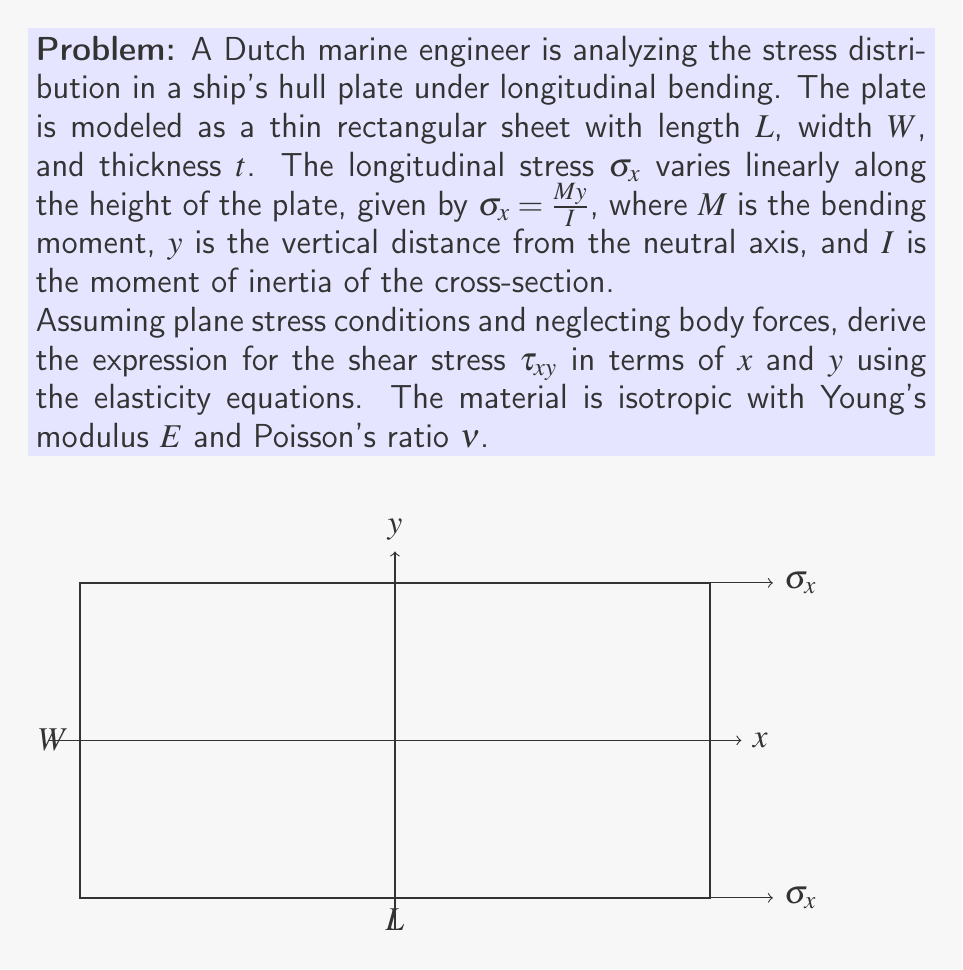Solve this math problem. To solve this problem, we'll use the elasticity equations and follow these steps:

1) First, recall the equilibrium equation for plane stress in the x-direction:

   $$\frac{\partial \sigma_x}{\partial x} + \frac{\partial \tau_{xy}}{\partial y} = 0$$

2) We're given that $\sigma_x = \frac{My}{I}$. Note that this is independent of $x$, so $\frac{\partial \sigma_x}{\partial x} = 0$.

3) Substituting this into the equilibrium equation:

   $$0 + \frac{\partial \tau_{xy}}{\partial y} = 0$$

4) This implies that $\tau_{xy}$ is only a function of $x$:

   $$\tau_{xy} = f(x)$$

5) To find $f(x)$, we use the compatibility equation in terms of stress for plane stress:

   $$\frac{\partial^2 \sigma_x}{\partial y^2} + \frac{\partial^2 \sigma_y}{\partial x^2} = 2(1+\nu)\frac{\partial^2 \tau_{xy}}{\partial x \partial y}$$

6) We know $\frac{\partial^2 \sigma_x}{\partial y^2} = 0$ (as $\sigma_x$ is linear in $y$). Also, $\sigma_y = 0$ for this loading condition. Therefore:

   $$0 = 2(1+\nu)\frac{\partial^2 \tau_{xy}}{\partial x \partial y}$$

7) This implies $\frac{\partial \tau_{xy}}{\partial x} = C$, where $C$ is a constant.

8) Integrating with respect to $x$:

   $$\tau_{xy} = Cx + D$$

9) To find $C$, we use the relation $\tau_{xy} = -\frac{Q}{I}\int_{-t/2}^y y dy$, where $Q$ is the shear force. Note that $Q = \frac{dM}{dx}$.

10) Differentiating $\tau_{xy}$ with respect to $x$:

    $$\frac{\partial \tau_{xy}}{\partial x} = -\frac{1}{I}\frac{dQ}{dx}\int_{-t/2}^y y dy = -\frac{1}{I}\frac{d^2M}{dx^2}\int_{-t/2}^y y dy$$

11) Therefore, $C = -\frac{1}{I}\frac{d^2M}{dx^2}\int_{-t/2}^y y dy$

12) The final expression for shear stress is:

    $$\tau_{xy} = -\frac{1}{I}\frac{d^2M}{dx^2}\int_{-t/2}^y y dy \cdot x + D$$

    where $D$ is determined by the boundary conditions.
Answer: $$\tau_{xy} = -\frac{1}{I}\frac{d^2M}{dx^2}\int_{-t/2}^y y dy \cdot x + D$$ 